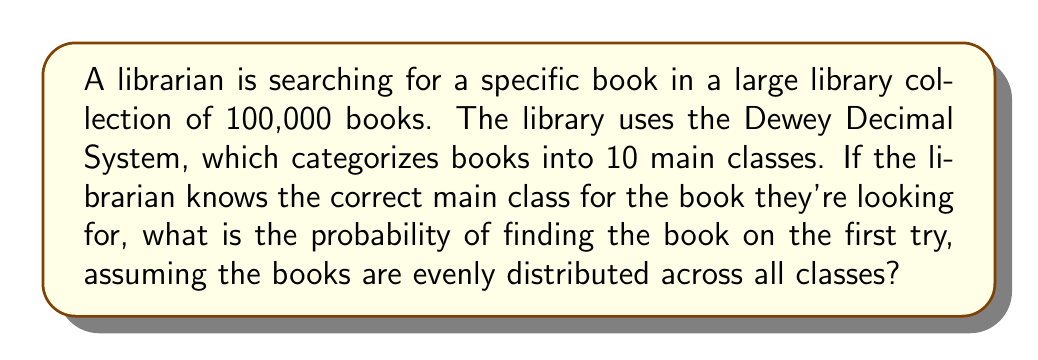Give your solution to this math problem. To solve this problem, we need to follow these steps:

1. Understand the given information:
   - The library has 100,000 books in total.
   - There are 10 main classes in the Dewey Decimal System.
   - The librarian knows the correct main class for the book.
   - Books are evenly distributed across all classes.

2. Calculate the number of books in each main class:
   Since the books are evenly distributed, we can divide the total number of books by the number of main classes.

   Books per class = Total books ÷ Number of classes
   $$ \text{Books per class} = \frac{100,000}{10} = 10,000 $$

3. Calculate the probability of finding the specific book:
   The probability of finding the book on the first try is equal to 1 divided by the number of books in the correct main class.

   $$ P(\text{finding the book}) = \frac{1}{\text{Books in the correct class}} = \frac{1}{10,000} = 0.0001 $$

This probability can also be expressed as a percentage:
$$ 0.0001 \times 100\% = 0.01\% $$
Answer: The probability of finding the specific book on the first try is $\frac{1}{10,000}$ or $0.0001$ (0.01%). 